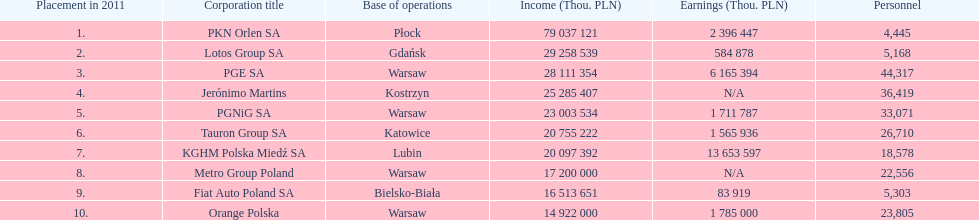What is the number of employees who work for pgnig sa? 33,071. 